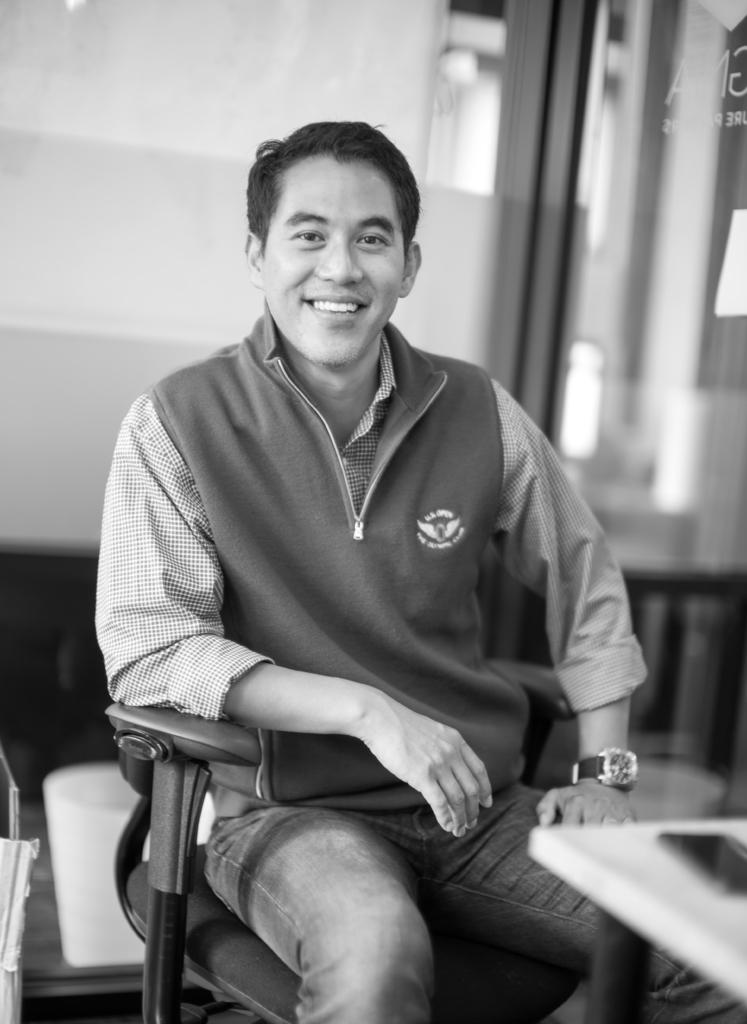What is the person in the image doing? The person is sitting on a chair in the image. What object is on the table in the image? There is a mobile on a table in the image. What can be seen behind the person in the image? There is a wall visible in the image. How would you describe the background of the image? The background of the image is blurred. What type of pot is the person holding in the image? There is no pot present in the image; the person is sitting on a chair. Is the police officer visible in the image? There is no police officer present in the image. 